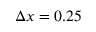Convert formula to latex. <formula><loc_0><loc_0><loc_500><loc_500>\Delta x = 0 . 2 5</formula> 